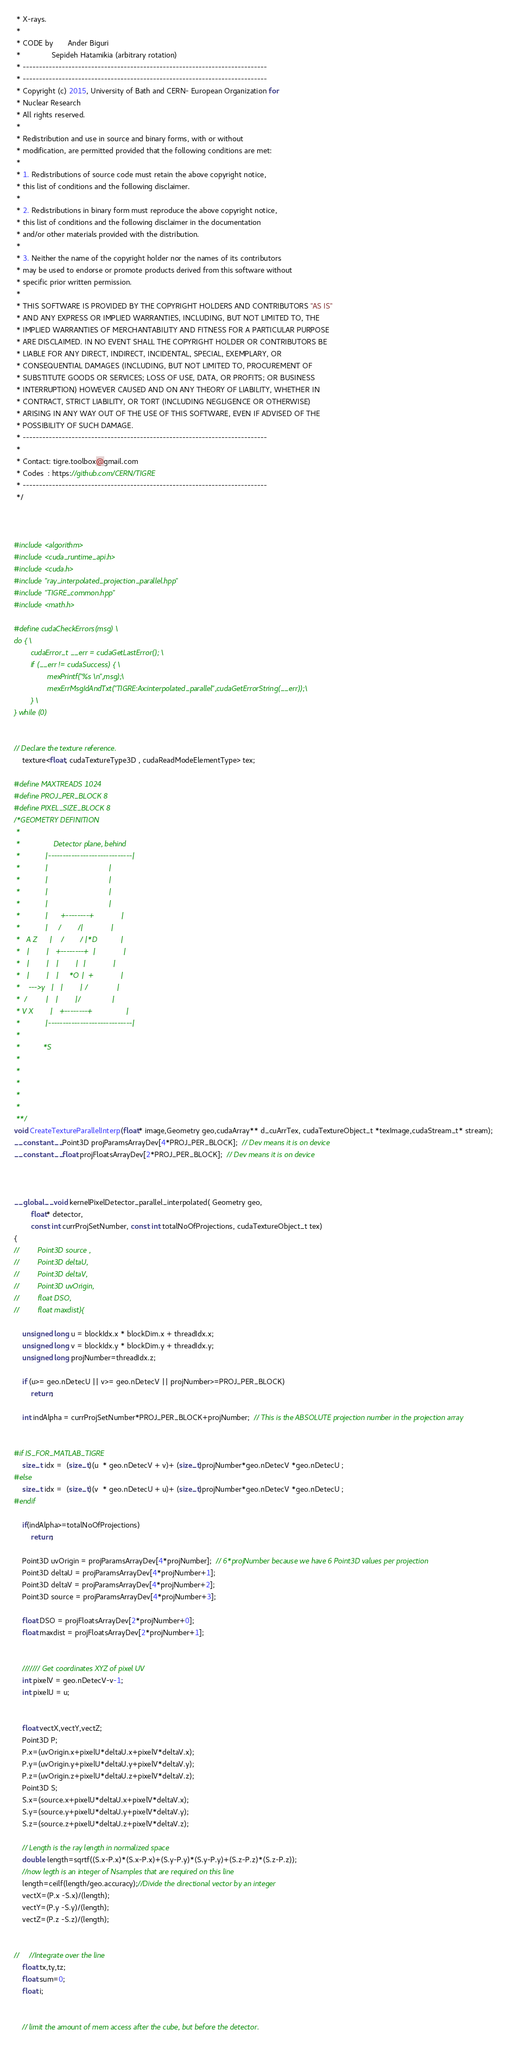<code> <loc_0><loc_0><loc_500><loc_500><_Cuda_> * X-rays.
 *
 * CODE by       Ander Biguri
 *               Sepideh Hatamikia (arbitrary rotation)
 * ---------------------------------------------------------------------------
 * ---------------------------------------------------------------------------
 * Copyright (c) 2015, University of Bath and CERN- European Organization for
 * Nuclear Research
 * All rights reserved.
 *
 * Redistribution and use in source and binary forms, with or without
 * modification, are permitted provided that the following conditions are met:
 *
 * 1. Redistributions of source code must retain the above copyright notice,
 * this list of conditions and the following disclaimer.
 *
 * 2. Redistributions in binary form must reproduce the above copyright notice,
 * this list of conditions and the following disclaimer in the documentation
 * and/or other materials provided with the distribution.
 *
 * 3. Neither the name of the copyright holder nor the names of its contributors
 * may be used to endorse or promote products derived from this software without
 * specific prior written permission.
 *
 * THIS SOFTWARE IS PROVIDED BY THE COPYRIGHT HOLDERS AND CONTRIBUTORS "AS IS"
 * AND ANY EXPRESS OR IMPLIED WARRANTIES, INCLUDING, BUT NOT LIMITED TO, THE
 * IMPLIED WARRANTIES OF MERCHANTABILITY AND FITNESS FOR A PARTICULAR PURPOSE
 * ARE DISCLAIMED. IN NO EVENT SHALL THE COPYRIGHT HOLDER OR CONTRIBUTORS BE
 * LIABLE FOR ANY DIRECT, INDIRECT, INCIDENTAL, SPECIAL, EXEMPLARY, OR
 * CONSEQUENTIAL DAMAGES (INCLUDING, BUT NOT LIMITED TO, PROCUREMENT OF
 * SUBSTITUTE GOODS OR SERVICES; LOSS OF USE, DATA, OR PROFITS; OR BUSINESS
 * INTERRUPTION) HOWEVER CAUSED AND ON ANY THEORY OF LIABILITY, WHETHER IN
 * CONTRACT, STRICT LIABILITY, OR TORT (INCLUDING NEGLIGENCE OR OTHERWISE)
 * ARISING IN ANY WAY OUT OF THE USE OF THIS SOFTWARE, EVEN IF ADVISED OF THE
 * POSSIBILITY OF SUCH DAMAGE.
 * ---------------------------------------------------------------------------
 *
 * Contact: tigre.toolbox@gmail.com
 * Codes  : https://github.com/CERN/TIGRE
 * ---------------------------------------------------------------------------
 */



#include <algorithm>
#include <cuda_runtime_api.h>
#include <cuda.h>
#include "ray_interpolated_projection_parallel.hpp"
#include "TIGRE_common.hpp"
#include <math.h>

#define cudaCheckErrors(msg) \
do { \
        cudaError_t __err = cudaGetLastError(); \
        if (__err != cudaSuccess) { \
                mexPrintf("%s \n",msg);\
                mexErrMsgIdAndTxt("TIGRE:Ax:interpolated_parallel",cudaGetErrorString(__err));\
        } \
} while (0)
    
    
// Declare the texture reference.
    texture<float, cudaTextureType3D , cudaReadModeElementType> tex;

#define MAXTREADS 1024
#define PROJ_PER_BLOCK 8
#define PIXEL_SIZE_BLOCK 8
/*GEOMETRY DEFINITION
 *
 *                Detector plane, behind
 *            |-----------------------------|
 *            |                             |
 *            |                             |
 *            |                             |
 *            |                             |
 *            |      +--------+             |
 *            |     /        /|             |
 *   A Z      |    /        / |*D           |
 *   |        |   +--------+  |             |
 *   |        |   |        |  |             |
 *   |        |   |     *O |  +             |
 *    --->y   |   |        | /              |
 *  /         |   |        |/               |
 * V X        |   +--------+                |
 *            |-----------------------------|
 *
 *           *S
 *
 *
 *
 *
 *
 **/
void CreateTextureParallelInterp(float* image,Geometry geo,cudaArray** d_cuArrTex, cudaTextureObject_t *texImage,cudaStream_t* stream);
__constant__ Point3D projParamsArrayDev[4*PROJ_PER_BLOCK];  // Dev means it is on device
__constant__ float projFloatsArrayDev[2*PROJ_PER_BLOCK];  // Dev means it is on device



__global__ void kernelPixelDetector_parallel_interpolated( Geometry geo,
        float* detector,
        const int currProjSetNumber, const int totalNoOfProjections, cudaTextureObject_t tex)
{
//         Point3D source ,
//         Point3D deltaU,
//         Point3D deltaV,
//         Point3D uvOrigin,
//         float DSO,
//         float maxdist){
    
    unsigned long u = blockIdx.x * blockDim.x + threadIdx.x;
    unsigned long v = blockIdx.y * blockDim.y + threadIdx.y;
    unsigned long projNumber=threadIdx.z;
    
    if (u>= geo.nDetecU || v>= geo.nDetecV || projNumber>=PROJ_PER_BLOCK)
        return;
    
    int indAlpha = currProjSetNumber*PROJ_PER_BLOCK+projNumber;  // This is the ABSOLUTE projection number in the projection array
    
    
#if IS_FOR_MATLAB_TIGRE
    size_t idx =  (size_t)(u  * geo.nDetecV + v)+ (size_t)projNumber*geo.nDetecV *geo.nDetecU ;
#else
    size_t idx =  (size_t)(v  * geo.nDetecU + u)+ (size_t)projNumber*geo.nDetecV *geo.nDetecU ;
#endif
    
    if(indAlpha>=totalNoOfProjections)
        return;
    
    Point3D uvOrigin = projParamsArrayDev[4*projNumber];  // 6*projNumber because we have 6 Point3D values per projection
    Point3D deltaU = projParamsArrayDev[4*projNumber+1];
    Point3D deltaV = projParamsArrayDev[4*projNumber+2];
    Point3D source = projParamsArrayDev[4*projNumber+3];
    
    float DSO = projFloatsArrayDev[2*projNumber+0];
    float maxdist = projFloatsArrayDev[2*projNumber+1];
    
    
    /////// Get coordinates XYZ of pixel UV
    int pixelV = geo.nDetecV-v-1;
    int pixelU = u;
    
    
    float vectX,vectY,vectZ;
    Point3D P;
    P.x=(uvOrigin.x+pixelU*deltaU.x+pixelV*deltaV.x);
    P.y=(uvOrigin.y+pixelU*deltaU.y+pixelV*deltaV.y);
    P.z=(uvOrigin.z+pixelU*deltaU.z+pixelV*deltaV.z);
    Point3D S;
    S.x=(source.x+pixelU*deltaU.x+pixelV*deltaV.x);
    S.y=(source.y+pixelU*deltaU.y+pixelV*deltaV.y);
    S.z=(source.z+pixelU*deltaU.z+pixelV*deltaV.z);
    
    // Length is the ray length in normalized space
    double length=sqrtf((S.x-P.x)*(S.x-P.x)+(S.y-P.y)*(S.y-P.y)+(S.z-P.z)*(S.z-P.z));
    //now legth is an integer of Nsamples that are required on this line
    length=ceilf(length/geo.accuracy);//Divide the directional vector by an integer
    vectX=(P.x -S.x)/(length);
    vectY=(P.y -S.y)/(length);
    vectZ=(P.z -S.z)/(length);
    
    
//     //Integrate over the line
    float tx,ty,tz;
    float sum=0;
    float i;
    
    
    // limit the amount of mem access after the cube, but before the detector.</code> 